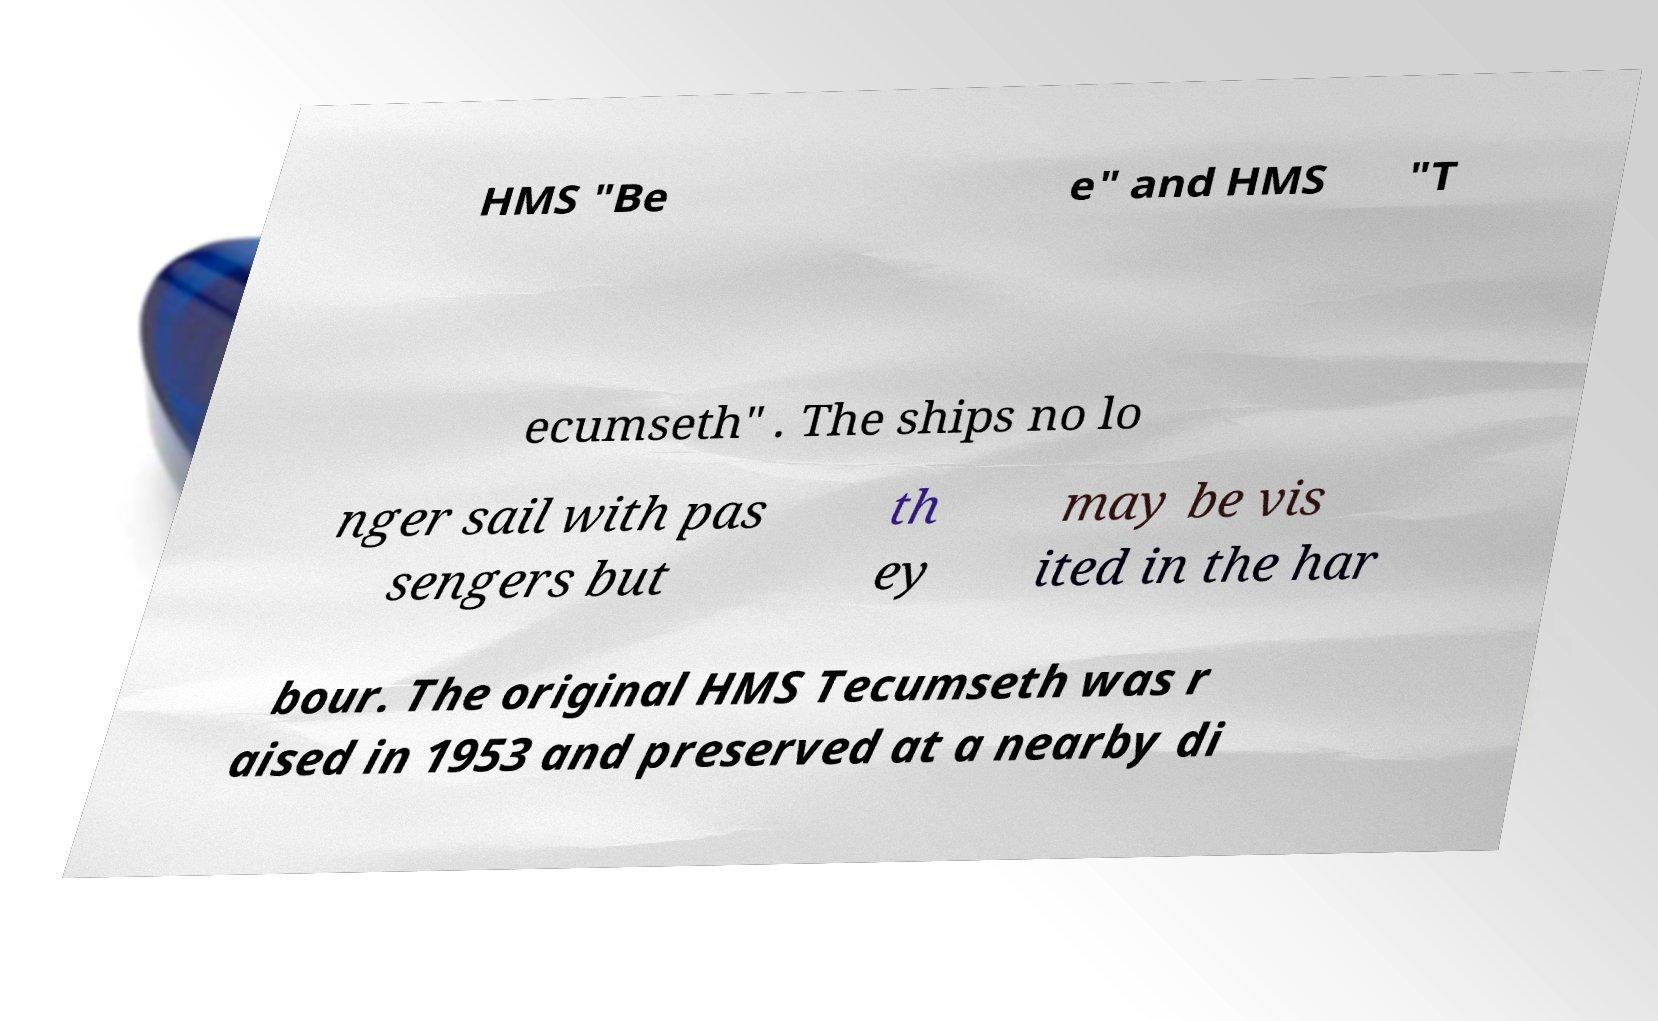Can you accurately transcribe the text from the provided image for me? HMS "Be e" and HMS "T ecumseth" . The ships no lo nger sail with pas sengers but th ey may be vis ited in the har bour. The original HMS Tecumseth was r aised in 1953 and preserved at a nearby di 